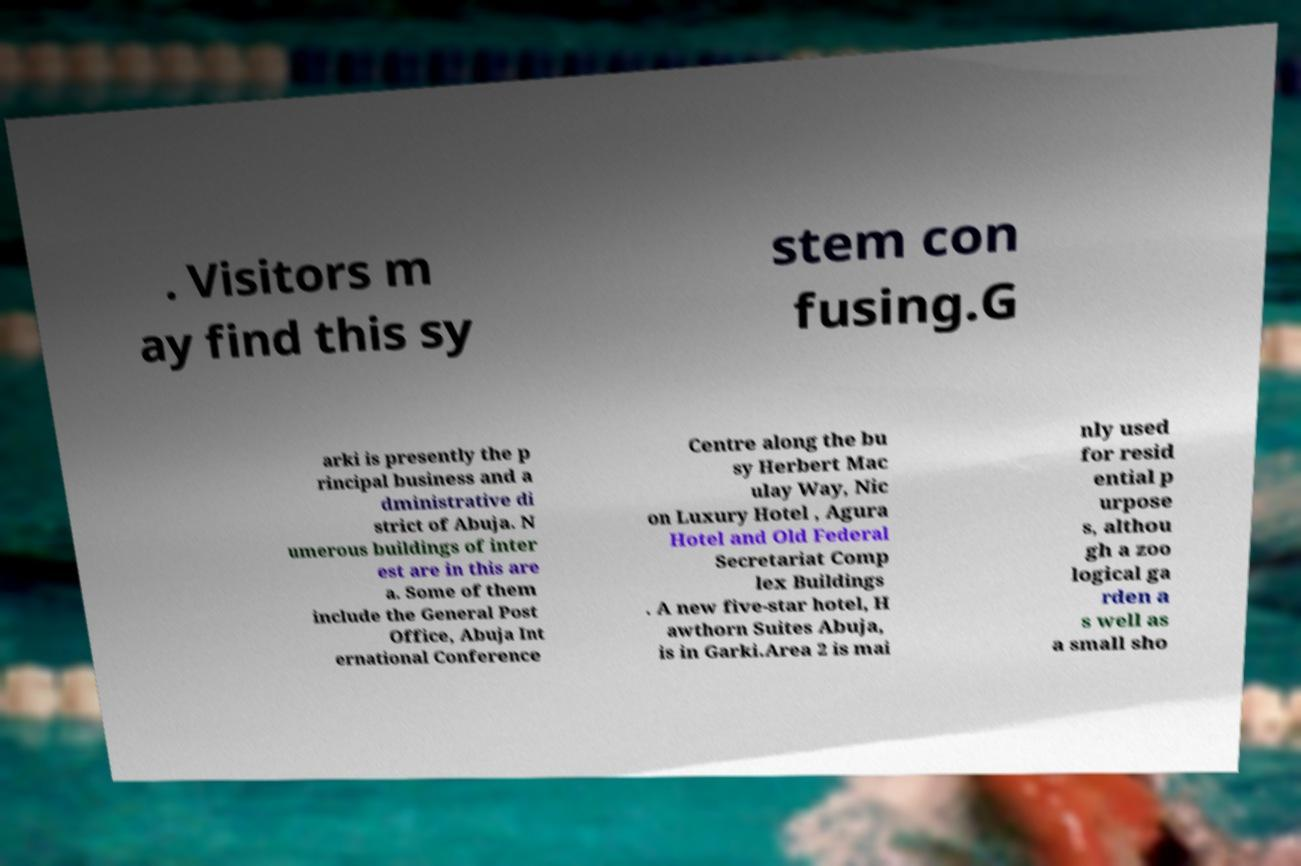There's text embedded in this image that I need extracted. Can you transcribe it verbatim? . Visitors m ay find this sy stem con fusing.G arki is presently the p rincipal business and a dministrative di strict of Abuja. N umerous buildings of inter est are in this are a. Some of them include the General Post Office, Abuja Int ernational Conference Centre along the bu sy Herbert Mac ulay Way, Nic on Luxury Hotel , Agura Hotel and Old Federal Secretariat Comp lex Buildings . A new five-star hotel, H awthorn Suites Abuja, is in Garki.Area 2 is mai nly used for resid ential p urpose s, althou gh a zoo logical ga rden a s well as a small sho 